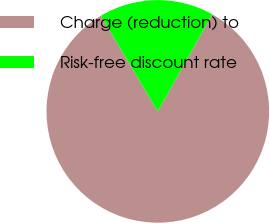<chart> <loc_0><loc_0><loc_500><loc_500><pie_chart><fcel>Charge (reduction) to<fcel>Risk-free discount rate<nl><fcel>83.33%<fcel>16.67%<nl></chart> 